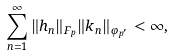Convert formula to latex. <formula><loc_0><loc_0><loc_500><loc_500>\sum _ { n = 1 } ^ { \infty } \| h _ { n } \| _ { F _ { p } } \| k _ { n } \| _ { \varphi _ { p ^ { \prime } } } < \infty ,</formula> 